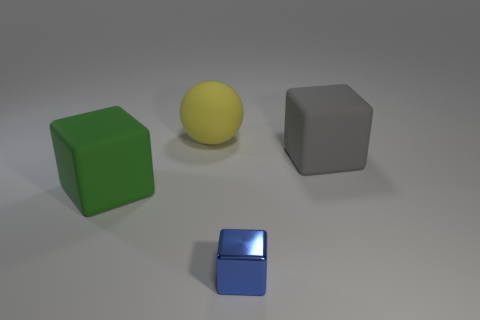Are there any other green blocks made of the same material as the large green block? Based on the image, there are no other blocks that share the same green color and material as the large green block. There's only one green block present, which has a matte finish, while the other objects consist of a yellow sphere, a gray block, and a smaller blue block, each with their own distinct colors and surfaces. 